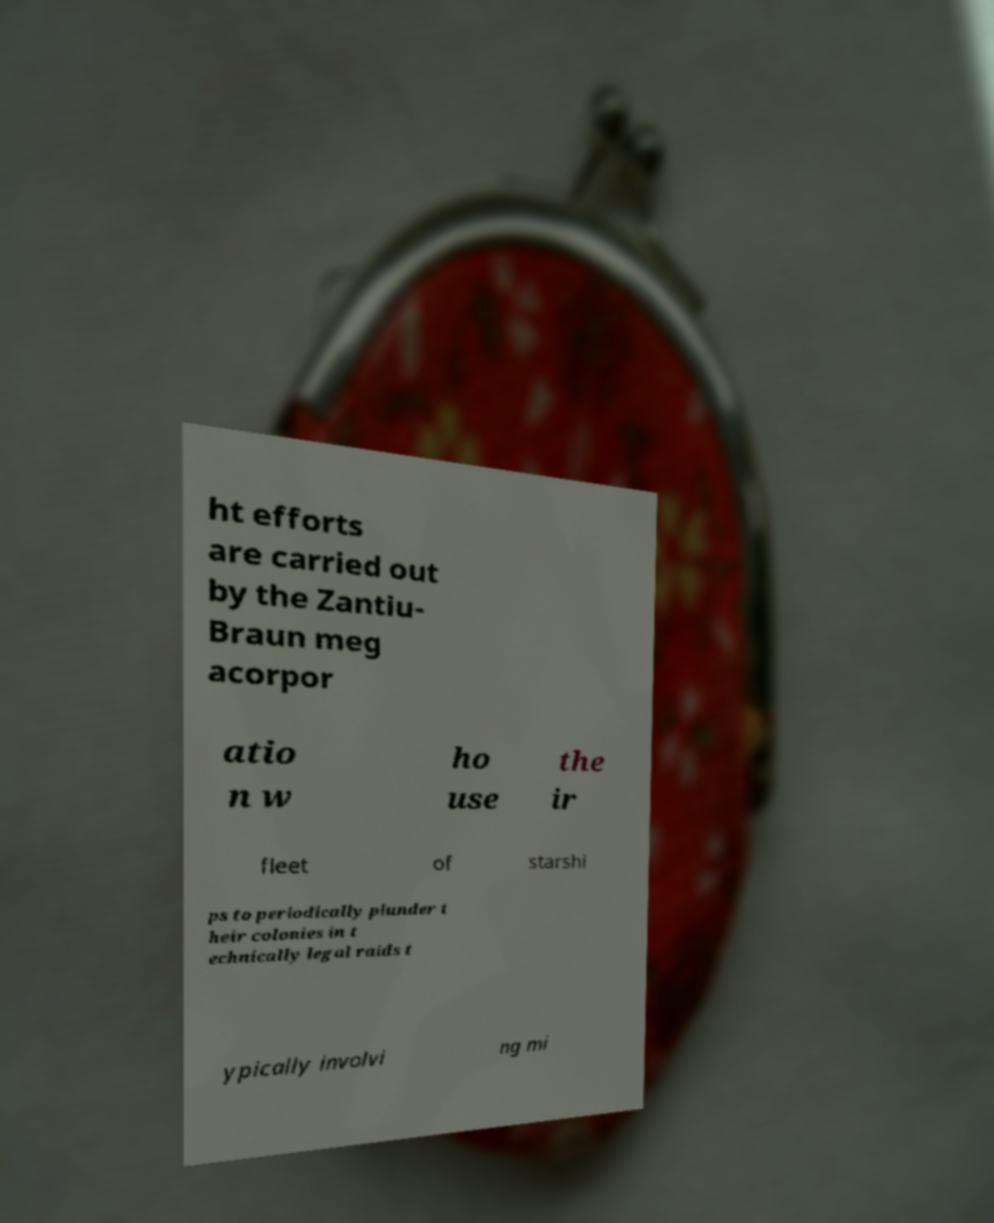There's text embedded in this image that I need extracted. Can you transcribe it verbatim? ht efforts are carried out by the Zantiu- Braun meg acorpor atio n w ho use the ir fleet of starshi ps to periodically plunder t heir colonies in t echnically legal raids t ypically involvi ng mi 